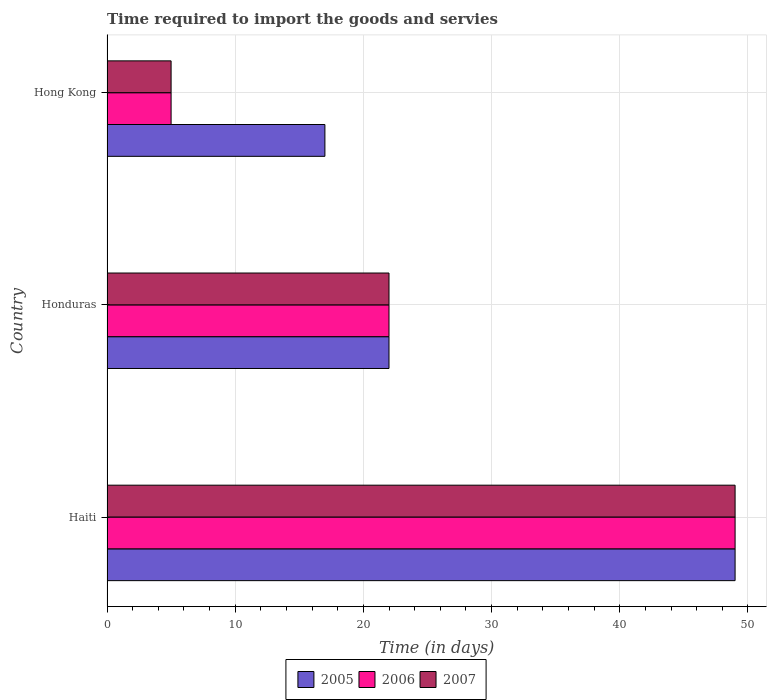How many different coloured bars are there?
Your answer should be very brief. 3. How many groups of bars are there?
Provide a short and direct response. 3. Are the number of bars on each tick of the Y-axis equal?
Provide a short and direct response. Yes. How many bars are there on the 1st tick from the top?
Provide a succinct answer. 3. How many bars are there on the 1st tick from the bottom?
Offer a very short reply. 3. What is the label of the 2nd group of bars from the top?
Provide a succinct answer. Honduras. In how many cases, is the number of bars for a given country not equal to the number of legend labels?
Provide a short and direct response. 0. Across all countries, what is the maximum number of days required to import the goods and services in 2007?
Provide a succinct answer. 49. In which country was the number of days required to import the goods and services in 2007 maximum?
Provide a short and direct response. Haiti. In which country was the number of days required to import the goods and services in 2005 minimum?
Give a very brief answer. Hong Kong. What is the difference between the number of days required to import the goods and services in 2005 in Haiti and that in Honduras?
Your response must be concise. 27. What is the difference between the number of days required to import the goods and services in 2007 in Hong Kong and the number of days required to import the goods and services in 2005 in Haiti?
Ensure brevity in your answer.  -44. What is the average number of days required to import the goods and services in 2005 per country?
Your answer should be very brief. 29.33. What is the ratio of the number of days required to import the goods and services in 2007 in Haiti to that in Hong Kong?
Offer a terse response. 9.8. In how many countries, is the number of days required to import the goods and services in 2006 greater than the average number of days required to import the goods and services in 2006 taken over all countries?
Provide a succinct answer. 1. Is the sum of the number of days required to import the goods and services in 2005 in Honduras and Hong Kong greater than the maximum number of days required to import the goods and services in 2007 across all countries?
Your answer should be compact. No. What does the 1st bar from the top in Honduras represents?
Keep it short and to the point. 2007. What does the 3rd bar from the bottom in Honduras represents?
Keep it short and to the point. 2007. How many bars are there?
Offer a terse response. 9. Are all the bars in the graph horizontal?
Offer a terse response. Yes. How many countries are there in the graph?
Keep it short and to the point. 3. Are the values on the major ticks of X-axis written in scientific E-notation?
Your answer should be compact. No. Does the graph contain grids?
Provide a succinct answer. Yes. Where does the legend appear in the graph?
Provide a short and direct response. Bottom center. How many legend labels are there?
Your answer should be very brief. 3. What is the title of the graph?
Provide a short and direct response. Time required to import the goods and servies. What is the label or title of the X-axis?
Ensure brevity in your answer.  Time (in days). What is the label or title of the Y-axis?
Ensure brevity in your answer.  Country. What is the Time (in days) in 2006 in Haiti?
Ensure brevity in your answer.  49. What is the Time (in days) in 2005 in Honduras?
Your answer should be very brief. 22. What is the Time (in days) in 2006 in Honduras?
Offer a terse response. 22. What is the Time (in days) in 2007 in Honduras?
Provide a short and direct response. 22. What is the Time (in days) in 2005 in Hong Kong?
Keep it short and to the point. 17. What is the Time (in days) in 2006 in Hong Kong?
Ensure brevity in your answer.  5. Across all countries, what is the maximum Time (in days) in 2006?
Ensure brevity in your answer.  49. Across all countries, what is the minimum Time (in days) of 2005?
Your answer should be very brief. 17. Across all countries, what is the minimum Time (in days) in 2006?
Your answer should be compact. 5. What is the total Time (in days) of 2005 in the graph?
Offer a terse response. 88. What is the total Time (in days) of 2006 in the graph?
Your answer should be very brief. 76. What is the total Time (in days) in 2007 in the graph?
Your response must be concise. 76. What is the difference between the Time (in days) of 2005 in Haiti and that in Honduras?
Your answer should be compact. 27. What is the difference between the Time (in days) of 2006 in Haiti and that in Honduras?
Your answer should be very brief. 27. What is the difference between the Time (in days) in 2005 in Haiti and that in Hong Kong?
Offer a terse response. 32. What is the difference between the Time (in days) of 2006 in Haiti and that in Hong Kong?
Your response must be concise. 44. What is the difference between the Time (in days) of 2007 in Haiti and that in Hong Kong?
Your response must be concise. 44. What is the difference between the Time (in days) of 2005 in Honduras and that in Hong Kong?
Offer a terse response. 5. What is the difference between the Time (in days) in 2005 in Haiti and the Time (in days) in 2006 in Honduras?
Ensure brevity in your answer.  27. What is the difference between the Time (in days) in 2005 in Haiti and the Time (in days) in 2007 in Honduras?
Your response must be concise. 27. What is the difference between the Time (in days) of 2006 in Haiti and the Time (in days) of 2007 in Honduras?
Ensure brevity in your answer.  27. What is the difference between the Time (in days) in 2005 in Haiti and the Time (in days) in 2007 in Hong Kong?
Ensure brevity in your answer.  44. What is the difference between the Time (in days) of 2006 in Haiti and the Time (in days) of 2007 in Hong Kong?
Your response must be concise. 44. What is the difference between the Time (in days) of 2005 in Honduras and the Time (in days) of 2006 in Hong Kong?
Your answer should be very brief. 17. What is the average Time (in days) in 2005 per country?
Your response must be concise. 29.33. What is the average Time (in days) in 2006 per country?
Keep it short and to the point. 25.33. What is the average Time (in days) in 2007 per country?
Your response must be concise. 25.33. What is the difference between the Time (in days) in 2005 and Time (in days) in 2006 in Honduras?
Your response must be concise. 0. What is the difference between the Time (in days) of 2005 and Time (in days) of 2007 in Honduras?
Offer a terse response. 0. What is the difference between the Time (in days) of 2005 and Time (in days) of 2007 in Hong Kong?
Your response must be concise. 12. What is the ratio of the Time (in days) in 2005 in Haiti to that in Honduras?
Your answer should be compact. 2.23. What is the ratio of the Time (in days) of 2006 in Haiti to that in Honduras?
Your response must be concise. 2.23. What is the ratio of the Time (in days) in 2007 in Haiti to that in Honduras?
Your answer should be compact. 2.23. What is the ratio of the Time (in days) in 2005 in Haiti to that in Hong Kong?
Keep it short and to the point. 2.88. What is the ratio of the Time (in days) in 2007 in Haiti to that in Hong Kong?
Offer a terse response. 9.8. What is the ratio of the Time (in days) of 2005 in Honduras to that in Hong Kong?
Ensure brevity in your answer.  1.29. What is the difference between the highest and the second highest Time (in days) of 2006?
Offer a very short reply. 27. What is the difference between the highest and the second highest Time (in days) of 2007?
Your response must be concise. 27. What is the difference between the highest and the lowest Time (in days) in 2007?
Keep it short and to the point. 44. 